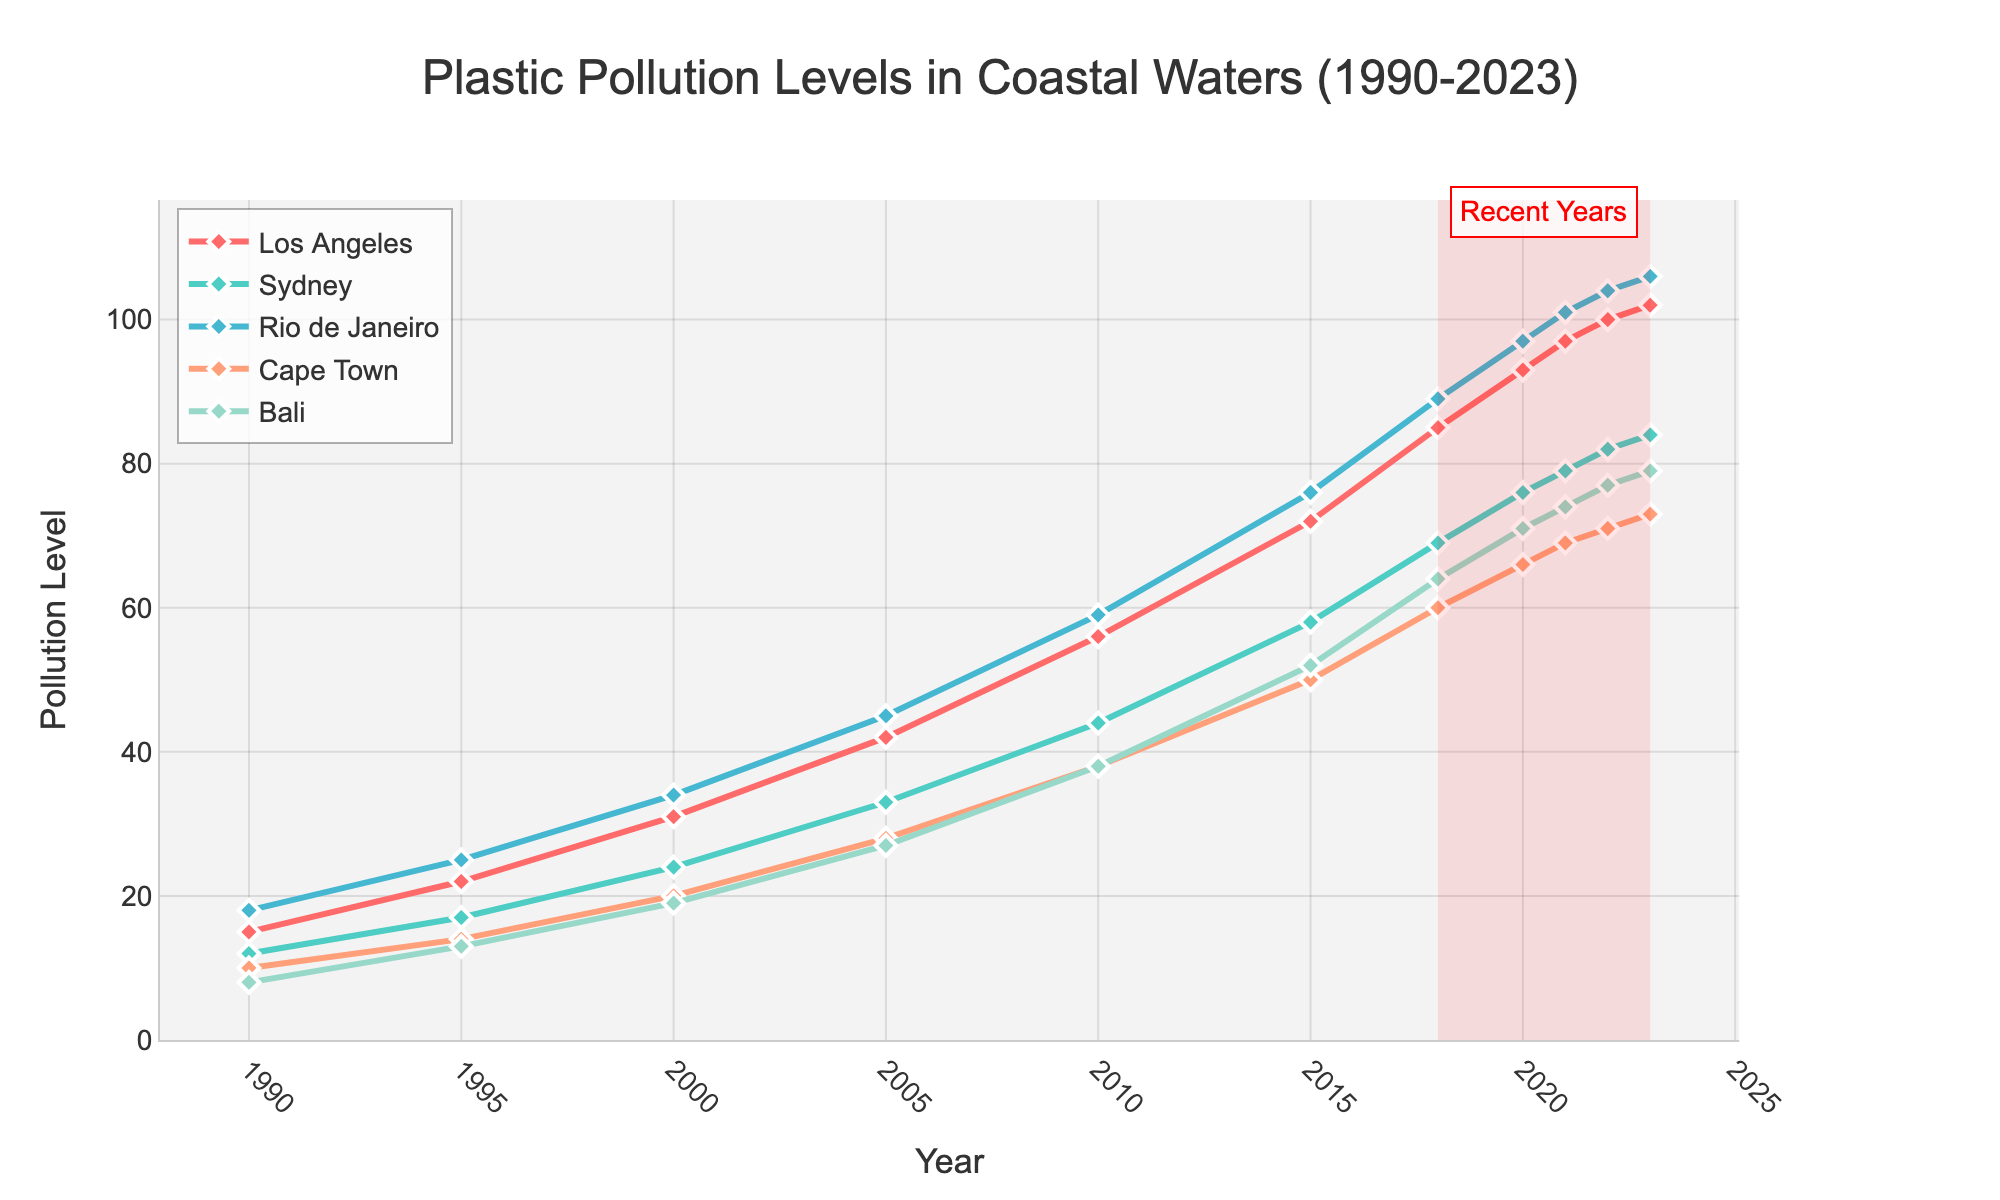What is the trend in plastic pollution levels in Los Angeles from 1990 to 2023? The trend shows a steady increase in plastic pollution levels in Los Angeles, rising from 15 in 1990 to 102 in 2023. This indicates consistent growth in pollution levels over the years.
Answer: Steady increase How does the pollution level in Bali in 2023 compare to that in 1995? In 1995, the pollution level in Bali was 13, and it increased to 79 in 2023. The difference in pollution levels between 1995 and 2023 is 79 - 13 = 66.
Answer: Bali's 2023 pollution level is 66 higher than in 1995 Which city had the highest increase in pollution levels between 2010 and 2020? Los Angeles had an increase of 93 - 56 = 37, Sydney had 76 - 44 = 32, Rio de Janeiro had 97 - 59 = 38, Cape Town had 66 - 38 = 28, and Bali had 71 - 38 = 33. Hence, Rio de Janeiro had the highest increase.
Answer: Rio de Janeiro What is the average pollution level across all cities in 2021? Add the pollution levels of all cities in 2021: 97 (LA) + 79 (Sydney) + 101 (Rio) + 69 (Cape Town) + 74 (Bali) = 420. The average is 420 / 5 = 84.
Answer: 84 Which city had the least pollution in 1990? Looking at the figure, Bali had the least pollution level in 1990 with a value of 8.
Answer: Bali By how much did the pollution levels in Cape Town change from 1990 to 2023? The pollution level in Cape Town was 10 in 1990 and increased to 73 in 2023. The change is 73 - 10 = 63.
Answer: 63 Which two cities have the most similar pollution levels in 2018? In 2018, Sydney had a pollution level of 69, and Cape Town had 60. These two levels are relatively close to each other with a difference of 69 - 60 = 9.
Answer: Sydney and Cape Town What is the overall trend for Sydney's pollution levels from 1990 to 2023? Sydney's pollution levels also show a steady increase from 12 in 1990 to 84 in 2023, indicating consistent growth in pollution.
Answer: Steady increase When did Los Angeles surpass Sydney in pollution levels? In 1995, Los Angeles had a pollution level of 22, while Sydney had 17, which indicates that Los Angeles surpassed Sydney in 1995.
Answer: 1995 